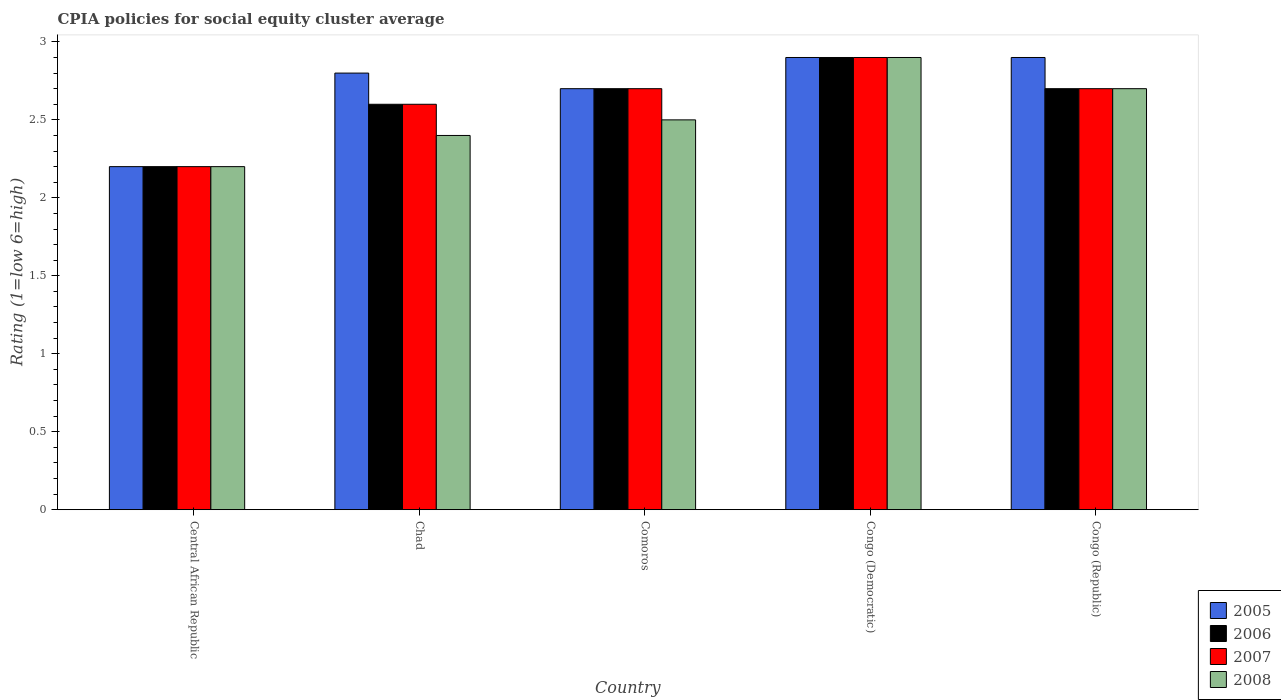How many groups of bars are there?
Provide a short and direct response. 5. How many bars are there on the 3rd tick from the left?
Provide a succinct answer. 4. What is the label of the 5th group of bars from the left?
Give a very brief answer. Congo (Republic). In how many cases, is the number of bars for a given country not equal to the number of legend labels?
Ensure brevity in your answer.  0. In which country was the CPIA rating in 2008 maximum?
Keep it short and to the point. Congo (Democratic). In which country was the CPIA rating in 2006 minimum?
Make the answer very short. Central African Republic. What is the total CPIA rating in 2007 in the graph?
Your response must be concise. 13.1. What is the difference between the CPIA rating in 2006 in Chad and that in Congo (Democratic)?
Offer a terse response. -0.3. What is the difference between the CPIA rating in 2007 in Chad and the CPIA rating in 2006 in Congo (Democratic)?
Your answer should be very brief. -0.3. What is the average CPIA rating in 2007 per country?
Provide a succinct answer. 2.62. What is the difference between the CPIA rating of/in 2007 and CPIA rating of/in 2008 in Central African Republic?
Your answer should be very brief. 0. In how many countries, is the CPIA rating in 2008 greater than 0.7?
Offer a very short reply. 5. What is the ratio of the CPIA rating in 2005 in Comoros to that in Congo (Republic)?
Your answer should be compact. 0.93. Is the CPIA rating in 2006 in Chad less than that in Congo (Democratic)?
Give a very brief answer. Yes. What is the difference between the highest and the second highest CPIA rating in 2008?
Make the answer very short. -0.4. What is the difference between the highest and the lowest CPIA rating in 2007?
Ensure brevity in your answer.  0.7. Is the sum of the CPIA rating in 2008 in Congo (Democratic) and Congo (Republic) greater than the maximum CPIA rating in 2005 across all countries?
Keep it short and to the point. Yes. Is it the case that in every country, the sum of the CPIA rating in 2006 and CPIA rating in 2008 is greater than the sum of CPIA rating in 2007 and CPIA rating in 2005?
Provide a succinct answer. No. What does the 2nd bar from the left in Chad represents?
Your answer should be compact. 2006. What does the 1st bar from the right in Congo (Democratic) represents?
Ensure brevity in your answer.  2008. How many bars are there?
Make the answer very short. 20. Are all the bars in the graph horizontal?
Make the answer very short. No. What is the difference between two consecutive major ticks on the Y-axis?
Offer a very short reply. 0.5. Where does the legend appear in the graph?
Provide a short and direct response. Bottom right. How many legend labels are there?
Offer a terse response. 4. What is the title of the graph?
Make the answer very short. CPIA policies for social equity cluster average. Does "2009" appear as one of the legend labels in the graph?
Your response must be concise. No. What is the label or title of the X-axis?
Provide a short and direct response. Country. What is the Rating (1=low 6=high) in 2005 in Central African Republic?
Offer a very short reply. 2.2. What is the Rating (1=low 6=high) of 2005 in Chad?
Give a very brief answer. 2.8. What is the Rating (1=low 6=high) in 2006 in Chad?
Provide a short and direct response. 2.6. What is the Rating (1=low 6=high) of 2007 in Chad?
Your answer should be compact. 2.6. What is the Rating (1=low 6=high) in 2008 in Chad?
Your response must be concise. 2.4. What is the Rating (1=low 6=high) in 2006 in Comoros?
Keep it short and to the point. 2.7. What is the Rating (1=low 6=high) in 2008 in Comoros?
Ensure brevity in your answer.  2.5. What is the Rating (1=low 6=high) of 2005 in Congo (Democratic)?
Ensure brevity in your answer.  2.9. What is the Rating (1=low 6=high) of 2006 in Congo (Republic)?
Offer a terse response. 2.7. Across all countries, what is the maximum Rating (1=low 6=high) in 2005?
Offer a very short reply. 2.9. Across all countries, what is the maximum Rating (1=low 6=high) in 2006?
Keep it short and to the point. 2.9. Across all countries, what is the maximum Rating (1=low 6=high) in 2008?
Make the answer very short. 2.9. Across all countries, what is the minimum Rating (1=low 6=high) of 2007?
Offer a very short reply. 2.2. What is the total Rating (1=low 6=high) of 2006 in the graph?
Your answer should be very brief. 13.1. What is the difference between the Rating (1=low 6=high) of 2006 in Central African Republic and that in Chad?
Your answer should be very brief. -0.4. What is the difference between the Rating (1=low 6=high) of 2007 in Central African Republic and that in Comoros?
Your answer should be compact. -0.5. What is the difference between the Rating (1=low 6=high) of 2008 in Central African Republic and that in Congo (Democratic)?
Give a very brief answer. -0.7. What is the difference between the Rating (1=low 6=high) of 2006 in Central African Republic and that in Congo (Republic)?
Provide a succinct answer. -0.5. What is the difference between the Rating (1=low 6=high) of 2007 in Central African Republic and that in Congo (Republic)?
Keep it short and to the point. -0.5. What is the difference between the Rating (1=low 6=high) in 2006 in Chad and that in Comoros?
Provide a succinct answer. -0.1. What is the difference between the Rating (1=low 6=high) of 2008 in Chad and that in Comoros?
Make the answer very short. -0.1. What is the difference between the Rating (1=low 6=high) of 2005 in Chad and that in Congo (Democratic)?
Give a very brief answer. -0.1. What is the difference between the Rating (1=low 6=high) in 2008 in Chad and that in Congo (Democratic)?
Keep it short and to the point. -0.5. What is the difference between the Rating (1=low 6=high) in 2005 in Chad and that in Congo (Republic)?
Provide a succinct answer. -0.1. What is the difference between the Rating (1=low 6=high) of 2005 in Comoros and that in Congo (Democratic)?
Your response must be concise. -0.2. What is the difference between the Rating (1=low 6=high) in 2007 in Comoros and that in Congo (Democratic)?
Provide a short and direct response. -0.2. What is the difference between the Rating (1=low 6=high) of 2007 in Comoros and that in Congo (Republic)?
Ensure brevity in your answer.  0. What is the difference between the Rating (1=low 6=high) of 2007 in Congo (Democratic) and that in Congo (Republic)?
Provide a short and direct response. 0.2. What is the difference between the Rating (1=low 6=high) in 2008 in Congo (Democratic) and that in Congo (Republic)?
Make the answer very short. 0.2. What is the difference between the Rating (1=low 6=high) in 2005 in Central African Republic and the Rating (1=low 6=high) in 2007 in Chad?
Ensure brevity in your answer.  -0.4. What is the difference between the Rating (1=low 6=high) in 2006 in Central African Republic and the Rating (1=low 6=high) in 2008 in Chad?
Give a very brief answer. -0.2. What is the difference between the Rating (1=low 6=high) in 2007 in Central African Republic and the Rating (1=low 6=high) in 2008 in Chad?
Offer a terse response. -0.2. What is the difference between the Rating (1=low 6=high) in 2005 in Central African Republic and the Rating (1=low 6=high) in 2006 in Comoros?
Your answer should be very brief. -0.5. What is the difference between the Rating (1=low 6=high) of 2005 in Central African Republic and the Rating (1=low 6=high) of 2007 in Comoros?
Your response must be concise. -0.5. What is the difference between the Rating (1=low 6=high) of 2005 in Central African Republic and the Rating (1=low 6=high) of 2008 in Comoros?
Your answer should be very brief. -0.3. What is the difference between the Rating (1=low 6=high) in 2006 in Central African Republic and the Rating (1=low 6=high) in 2007 in Comoros?
Ensure brevity in your answer.  -0.5. What is the difference between the Rating (1=low 6=high) of 2005 in Central African Republic and the Rating (1=low 6=high) of 2007 in Congo (Democratic)?
Keep it short and to the point. -0.7. What is the difference between the Rating (1=low 6=high) of 2005 in Central African Republic and the Rating (1=low 6=high) of 2008 in Congo (Democratic)?
Keep it short and to the point. -0.7. What is the difference between the Rating (1=low 6=high) of 2005 in Central African Republic and the Rating (1=low 6=high) of 2006 in Congo (Republic)?
Keep it short and to the point. -0.5. What is the difference between the Rating (1=low 6=high) in 2005 in Central African Republic and the Rating (1=low 6=high) in 2007 in Congo (Republic)?
Ensure brevity in your answer.  -0.5. What is the difference between the Rating (1=low 6=high) in 2006 in Central African Republic and the Rating (1=low 6=high) in 2007 in Congo (Republic)?
Your response must be concise. -0.5. What is the difference between the Rating (1=low 6=high) of 2007 in Central African Republic and the Rating (1=low 6=high) of 2008 in Congo (Republic)?
Offer a terse response. -0.5. What is the difference between the Rating (1=low 6=high) of 2005 in Chad and the Rating (1=low 6=high) of 2006 in Comoros?
Your response must be concise. 0.1. What is the difference between the Rating (1=low 6=high) in 2006 in Chad and the Rating (1=low 6=high) in 2008 in Comoros?
Your answer should be compact. 0.1. What is the difference between the Rating (1=low 6=high) in 2007 in Chad and the Rating (1=low 6=high) in 2008 in Comoros?
Offer a terse response. 0.1. What is the difference between the Rating (1=low 6=high) of 2005 in Chad and the Rating (1=low 6=high) of 2006 in Congo (Democratic)?
Offer a very short reply. -0.1. What is the difference between the Rating (1=low 6=high) of 2005 in Chad and the Rating (1=low 6=high) of 2008 in Congo (Democratic)?
Provide a short and direct response. -0.1. What is the difference between the Rating (1=low 6=high) of 2006 in Chad and the Rating (1=low 6=high) of 2007 in Congo (Democratic)?
Your answer should be very brief. -0.3. What is the difference between the Rating (1=low 6=high) in 2007 in Chad and the Rating (1=low 6=high) in 2008 in Congo (Democratic)?
Give a very brief answer. -0.3. What is the difference between the Rating (1=low 6=high) of 2005 in Chad and the Rating (1=low 6=high) of 2006 in Congo (Republic)?
Your answer should be compact. 0.1. What is the difference between the Rating (1=low 6=high) of 2006 in Chad and the Rating (1=low 6=high) of 2007 in Congo (Republic)?
Your answer should be very brief. -0.1. What is the difference between the Rating (1=low 6=high) in 2007 in Chad and the Rating (1=low 6=high) in 2008 in Congo (Republic)?
Ensure brevity in your answer.  -0.1. What is the difference between the Rating (1=low 6=high) of 2005 in Comoros and the Rating (1=low 6=high) of 2006 in Congo (Democratic)?
Keep it short and to the point. -0.2. What is the difference between the Rating (1=low 6=high) in 2005 in Comoros and the Rating (1=low 6=high) in 2007 in Congo (Democratic)?
Make the answer very short. -0.2. What is the difference between the Rating (1=low 6=high) in 2005 in Comoros and the Rating (1=low 6=high) in 2008 in Congo (Democratic)?
Offer a terse response. -0.2. What is the difference between the Rating (1=low 6=high) in 2006 in Comoros and the Rating (1=low 6=high) in 2008 in Congo (Democratic)?
Offer a very short reply. -0.2. What is the difference between the Rating (1=low 6=high) in 2007 in Comoros and the Rating (1=low 6=high) in 2008 in Congo (Democratic)?
Keep it short and to the point. -0.2. What is the difference between the Rating (1=low 6=high) in 2005 in Comoros and the Rating (1=low 6=high) in 2007 in Congo (Republic)?
Provide a succinct answer. 0. What is the difference between the Rating (1=low 6=high) in 2006 in Comoros and the Rating (1=low 6=high) in 2007 in Congo (Republic)?
Give a very brief answer. 0. What is the difference between the Rating (1=low 6=high) in 2006 in Comoros and the Rating (1=low 6=high) in 2008 in Congo (Republic)?
Provide a short and direct response. 0. What is the difference between the Rating (1=low 6=high) of 2005 in Congo (Democratic) and the Rating (1=low 6=high) of 2006 in Congo (Republic)?
Your response must be concise. 0.2. What is the difference between the Rating (1=low 6=high) in 2006 in Congo (Democratic) and the Rating (1=low 6=high) in 2008 in Congo (Republic)?
Keep it short and to the point. 0.2. What is the difference between the Rating (1=low 6=high) of 2007 in Congo (Democratic) and the Rating (1=low 6=high) of 2008 in Congo (Republic)?
Ensure brevity in your answer.  0.2. What is the average Rating (1=low 6=high) of 2005 per country?
Your answer should be very brief. 2.7. What is the average Rating (1=low 6=high) in 2006 per country?
Your response must be concise. 2.62. What is the average Rating (1=low 6=high) in 2007 per country?
Offer a terse response. 2.62. What is the average Rating (1=low 6=high) of 2008 per country?
Give a very brief answer. 2.54. What is the difference between the Rating (1=low 6=high) of 2005 and Rating (1=low 6=high) of 2006 in Central African Republic?
Keep it short and to the point. 0. What is the difference between the Rating (1=low 6=high) of 2006 and Rating (1=low 6=high) of 2007 in Central African Republic?
Offer a terse response. 0. What is the difference between the Rating (1=low 6=high) in 2006 and Rating (1=low 6=high) in 2008 in Central African Republic?
Provide a short and direct response. 0. What is the difference between the Rating (1=low 6=high) of 2007 and Rating (1=low 6=high) of 2008 in Central African Republic?
Your response must be concise. 0. What is the difference between the Rating (1=low 6=high) in 2005 and Rating (1=low 6=high) in 2006 in Chad?
Ensure brevity in your answer.  0.2. What is the difference between the Rating (1=low 6=high) in 2005 and Rating (1=low 6=high) in 2008 in Chad?
Your response must be concise. 0.4. What is the difference between the Rating (1=low 6=high) in 2006 and Rating (1=low 6=high) in 2007 in Chad?
Make the answer very short. 0. What is the difference between the Rating (1=low 6=high) in 2006 and Rating (1=low 6=high) in 2007 in Comoros?
Your answer should be compact. 0. What is the difference between the Rating (1=low 6=high) in 2006 and Rating (1=low 6=high) in 2008 in Comoros?
Provide a succinct answer. 0.2. What is the difference between the Rating (1=low 6=high) in 2005 and Rating (1=low 6=high) in 2007 in Congo (Democratic)?
Provide a succinct answer. 0. What is the difference between the Rating (1=low 6=high) of 2005 and Rating (1=low 6=high) of 2008 in Congo (Democratic)?
Make the answer very short. 0. What is the difference between the Rating (1=low 6=high) of 2006 and Rating (1=low 6=high) of 2008 in Congo (Democratic)?
Ensure brevity in your answer.  0. What is the difference between the Rating (1=low 6=high) of 2007 and Rating (1=low 6=high) of 2008 in Congo (Democratic)?
Provide a short and direct response. 0. What is the difference between the Rating (1=low 6=high) in 2005 and Rating (1=low 6=high) in 2006 in Congo (Republic)?
Offer a terse response. 0.2. What is the difference between the Rating (1=low 6=high) in 2005 and Rating (1=low 6=high) in 2008 in Congo (Republic)?
Ensure brevity in your answer.  0.2. What is the ratio of the Rating (1=low 6=high) in 2005 in Central African Republic to that in Chad?
Keep it short and to the point. 0.79. What is the ratio of the Rating (1=low 6=high) in 2006 in Central African Republic to that in Chad?
Your answer should be compact. 0.85. What is the ratio of the Rating (1=low 6=high) of 2007 in Central African Republic to that in Chad?
Your answer should be very brief. 0.85. What is the ratio of the Rating (1=low 6=high) in 2008 in Central African Republic to that in Chad?
Make the answer very short. 0.92. What is the ratio of the Rating (1=low 6=high) in 2005 in Central African Republic to that in Comoros?
Your answer should be very brief. 0.81. What is the ratio of the Rating (1=low 6=high) of 2006 in Central African Republic to that in Comoros?
Provide a succinct answer. 0.81. What is the ratio of the Rating (1=low 6=high) of 2007 in Central African Republic to that in Comoros?
Provide a succinct answer. 0.81. What is the ratio of the Rating (1=low 6=high) in 2008 in Central African Republic to that in Comoros?
Offer a very short reply. 0.88. What is the ratio of the Rating (1=low 6=high) of 2005 in Central African Republic to that in Congo (Democratic)?
Your answer should be compact. 0.76. What is the ratio of the Rating (1=low 6=high) in 2006 in Central African Republic to that in Congo (Democratic)?
Give a very brief answer. 0.76. What is the ratio of the Rating (1=low 6=high) of 2007 in Central African Republic to that in Congo (Democratic)?
Your answer should be compact. 0.76. What is the ratio of the Rating (1=low 6=high) of 2008 in Central African Republic to that in Congo (Democratic)?
Your response must be concise. 0.76. What is the ratio of the Rating (1=low 6=high) in 2005 in Central African Republic to that in Congo (Republic)?
Your answer should be compact. 0.76. What is the ratio of the Rating (1=low 6=high) of 2006 in Central African Republic to that in Congo (Republic)?
Make the answer very short. 0.81. What is the ratio of the Rating (1=low 6=high) in 2007 in Central African Republic to that in Congo (Republic)?
Provide a succinct answer. 0.81. What is the ratio of the Rating (1=low 6=high) in 2008 in Central African Republic to that in Congo (Republic)?
Offer a terse response. 0.81. What is the ratio of the Rating (1=low 6=high) of 2005 in Chad to that in Comoros?
Your answer should be very brief. 1.04. What is the ratio of the Rating (1=low 6=high) in 2007 in Chad to that in Comoros?
Provide a short and direct response. 0.96. What is the ratio of the Rating (1=low 6=high) of 2008 in Chad to that in Comoros?
Offer a very short reply. 0.96. What is the ratio of the Rating (1=low 6=high) in 2005 in Chad to that in Congo (Democratic)?
Offer a very short reply. 0.97. What is the ratio of the Rating (1=low 6=high) of 2006 in Chad to that in Congo (Democratic)?
Your answer should be very brief. 0.9. What is the ratio of the Rating (1=low 6=high) in 2007 in Chad to that in Congo (Democratic)?
Offer a terse response. 0.9. What is the ratio of the Rating (1=low 6=high) of 2008 in Chad to that in Congo (Democratic)?
Ensure brevity in your answer.  0.83. What is the ratio of the Rating (1=low 6=high) in 2005 in Chad to that in Congo (Republic)?
Make the answer very short. 0.97. What is the ratio of the Rating (1=low 6=high) in 2006 in Chad to that in Congo (Republic)?
Make the answer very short. 0.96. What is the ratio of the Rating (1=low 6=high) in 2007 in Chad to that in Congo (Republic)?
Provide a short and direct response. 0.96. What is the ratio of the Rating (1=low 6=high) of 2008 in Chad to that in Congo (Republic)?
Offer a very short reply. 0.89. What is the ratio of the Rating (1=low 6=high) of 2007 in Comoros to that in Congo (Democratic)?
Provide a succinct answer. 0.93. What is the ratio of the Rating (1=low 6=high) in 2008 in Comoros to that in Congo (Democratic)?
Provide a short and direct response. 0.86. What is the ratio of the Rating (1=low 6=high) in 2005 in Comoros to that in Congo (Republic)?
Keep it short and to the point. 0.93. What is the ratio of the Rating (1=low 6=high) in 2008 in Comoros to that in Congo (Republic)?
Give a very brief answer. 0.93. What is the ratio of the Rating (1=low 6=high) in 2006 in Congo (Democratic) to that in Congo (Republic)?
Provide a succinct answer. 1.07. What is the ratio of the Rating (1=low 6=high) in 2007 in Congo (Democratic) to that in Congo (Republic)?
Keep it short and to the point. 1.07. What is the ratio of the Rating (1=low 6=high) in 2008 in Congo (Democratic) to that in Congo (Republic)?
Provide a succinct answer. 1.07. What is the difference between the highest and the second highest Rating (1=low 6=high) in 2005?
Provide a succinct answer. 0. What is the difference between the highest and the second highest Rating (1=low 6=high) of 2006?
Offer a very short reply. 0.2. What is the difference between the highest and the second highest Rating (1=low 6=high) of 2007?
Keep it short and to the point. 0.2. What is the difference between the highest and the lowest Rating (1=low 6=high) in 2005?
Offer a very short reply. 0.7. What is the difference between the highest and the lowest Rating (1=low 6=high) of 2006?
Your answer should be very brief. 0.7. What is the difference between the highest and the lowest Rating (1=low 6=high) in 2008?
Provide a short and direct response. 0.7. 